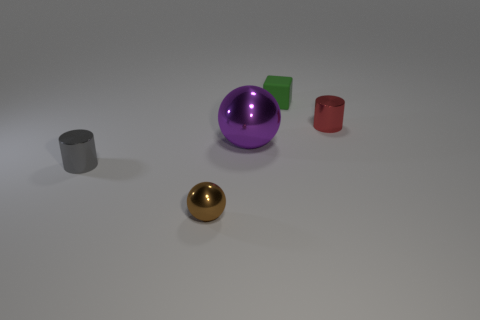Are there any other things that have the same size as the purple ball?
Provide a short and direct response. No. Is there anything else that is made of the same material as the small green cube?
Give a very brief answer. No. Do the cube and the cylinder that is left of the large purple thing have the same color?
Your answer should be compact. No. What shape is the tiny red shiny object?
Your answer should be very brief. Cylinder. There is a cylinder that is on the left side of the purple object that is in front of the object right of the small block; what size is it?
Provide a succinct answer. Small. How many other objects are there of the same shape as the green object?
Your response must be concise. 0. There is a small object that is right of the tiny rubber block; is its shape the same as the thing that is in front of the small gray metallic cylinder?
Keep it short and to the point. No. How many cylinders are tiny red metal objects or rubber things?
Make the answer very short. 1. There is a thing on the left side of the metal thing in front of the tiny shiny cylinder to the left of the tiny red shiny object; what is its material?
Provide a short and direct response. Metal. How many other things are the same size as the green block?
Your answer should be compact. 3. 